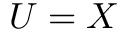<formula> <loc_0><loc_0><loc_500><loc_500>U = X</formula> 